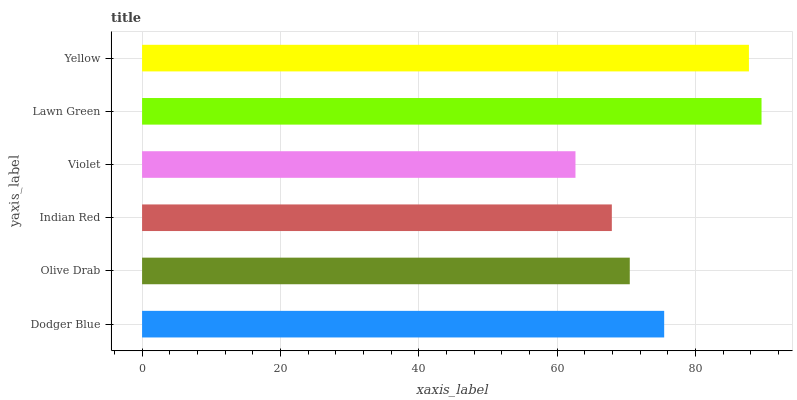Is Violet the minimum?
Answer yes or no. Yes. Is Lawn Green the maximum?
Answer yes or no. Yes. Is Olive Drab the minimum?
Answer yes or no. No. Is Olive Drab the maximum?
Answer yes or no. No. Is Dodger Blue greater than Olive Drab?
Answer yes or no. Yes. Is Olive Drab less than Dodger Blue?
Answer yes or no. Yes. Is Olive Drab greater than Dodger Blue?
Answer yes or no. No. Is Dodger Blue less than Olive Drab?
Answer yes or no. No. Is Dodger Blue the high median?
Answer yes or no. Yes. Is Olive Drab the low median?
Answer yes or no. Yes. Is Yellow the high median?
Answer yes or no. No. Is Dodger Blue the low median?
Answer yes or no. No. 